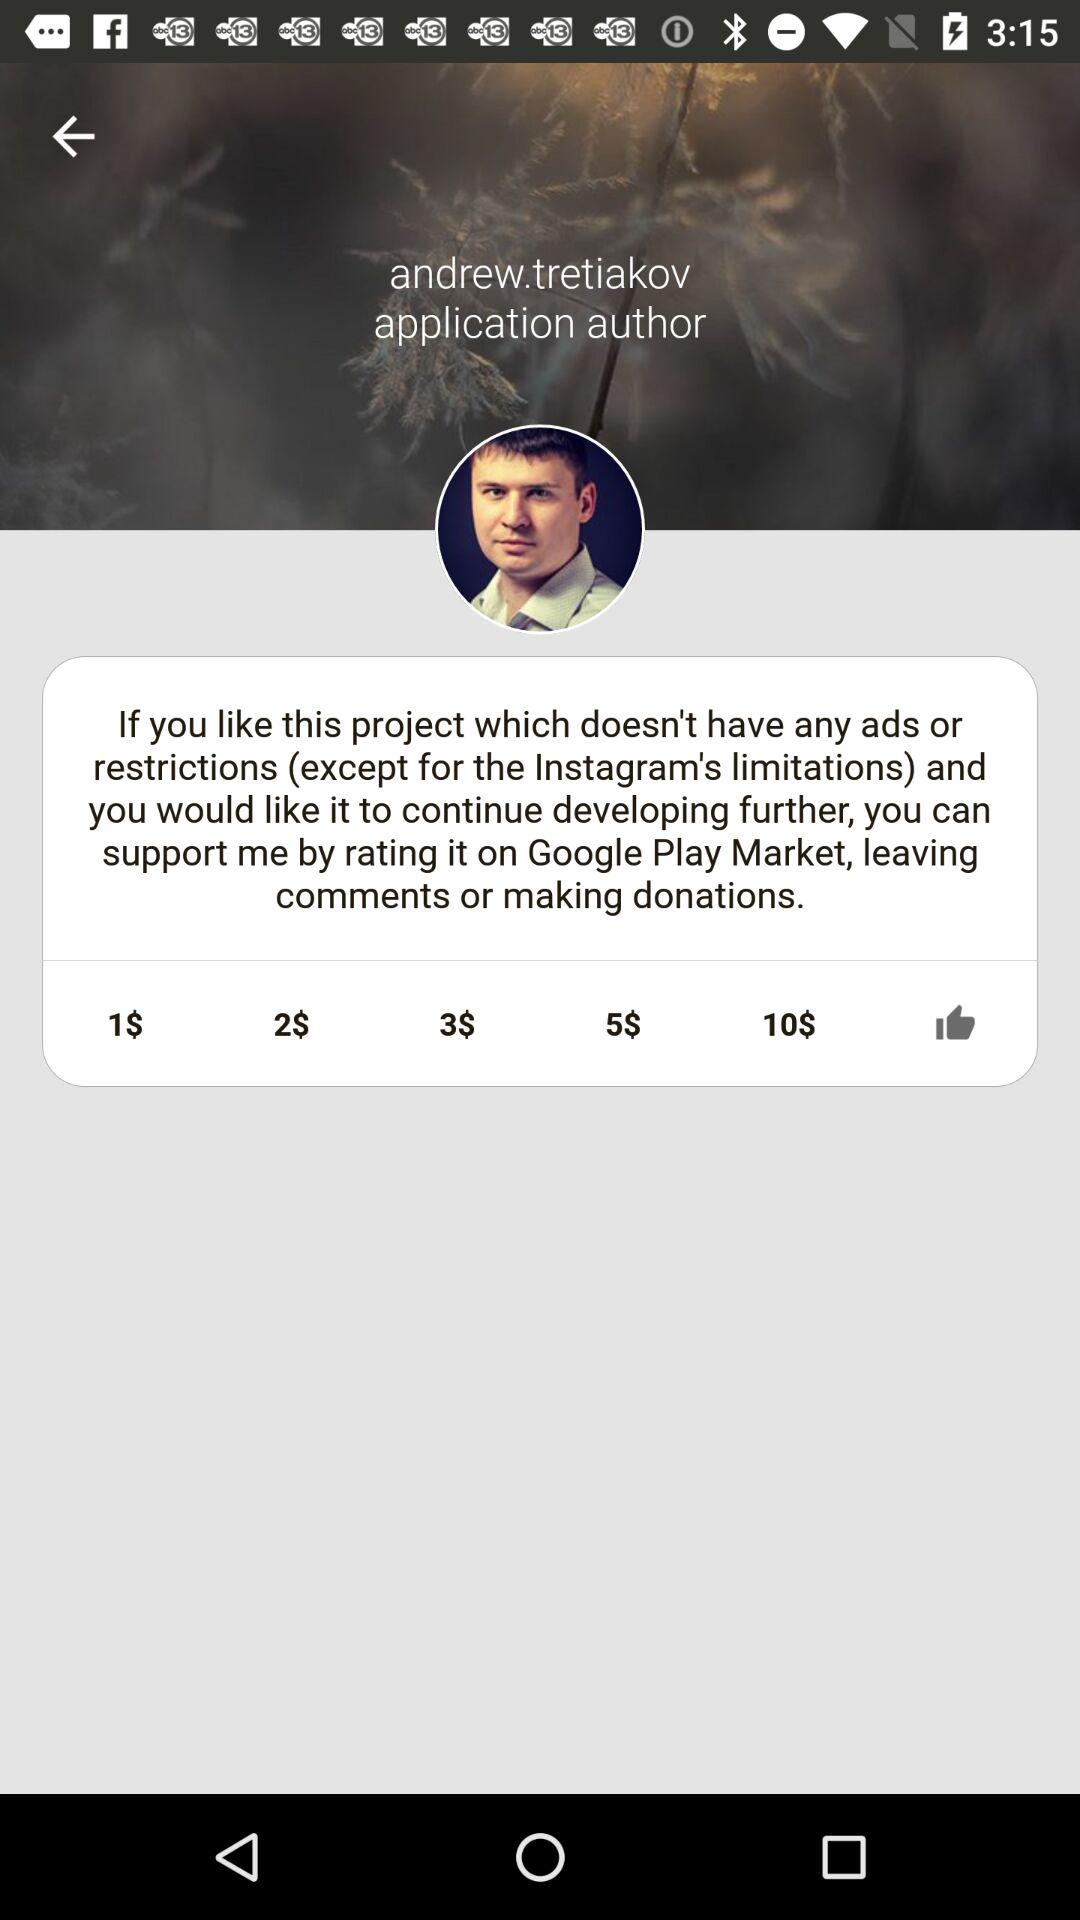Who is the application's author? The applications's author is "andrew.tretiakov". 